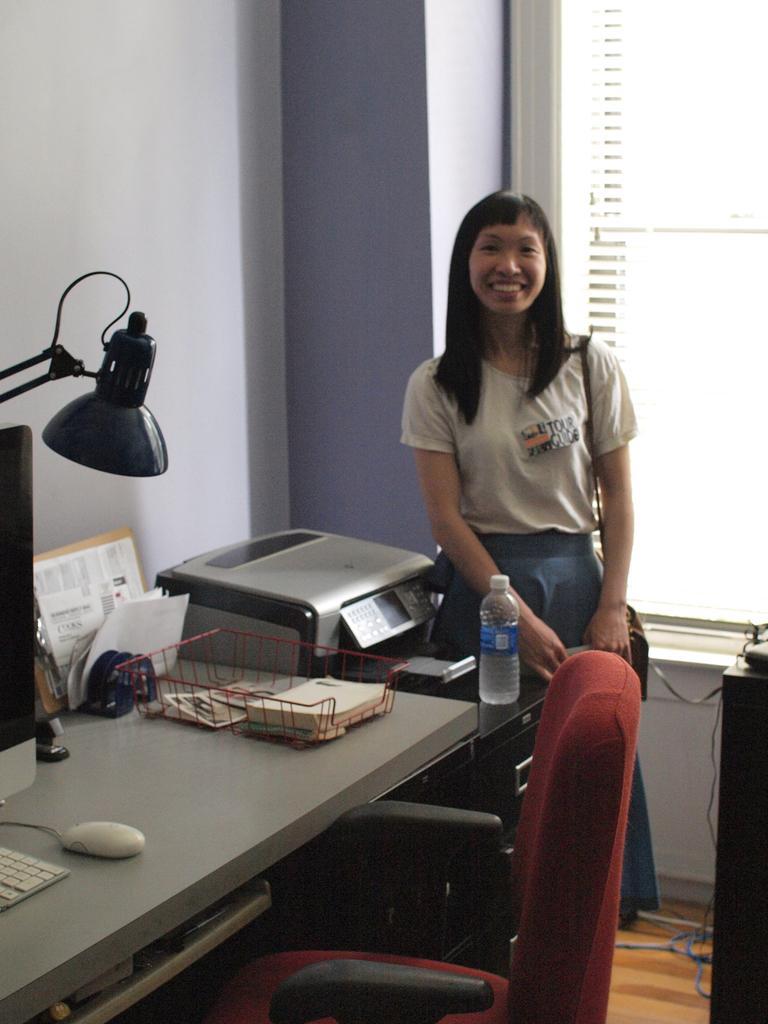Describe this image in one or two sentences. This is the picture of a lady in white shirt who is standing beside the printer and in front of her there is a table on which there is a system, mouse and stand a bottle and also a chair and a lamp. 